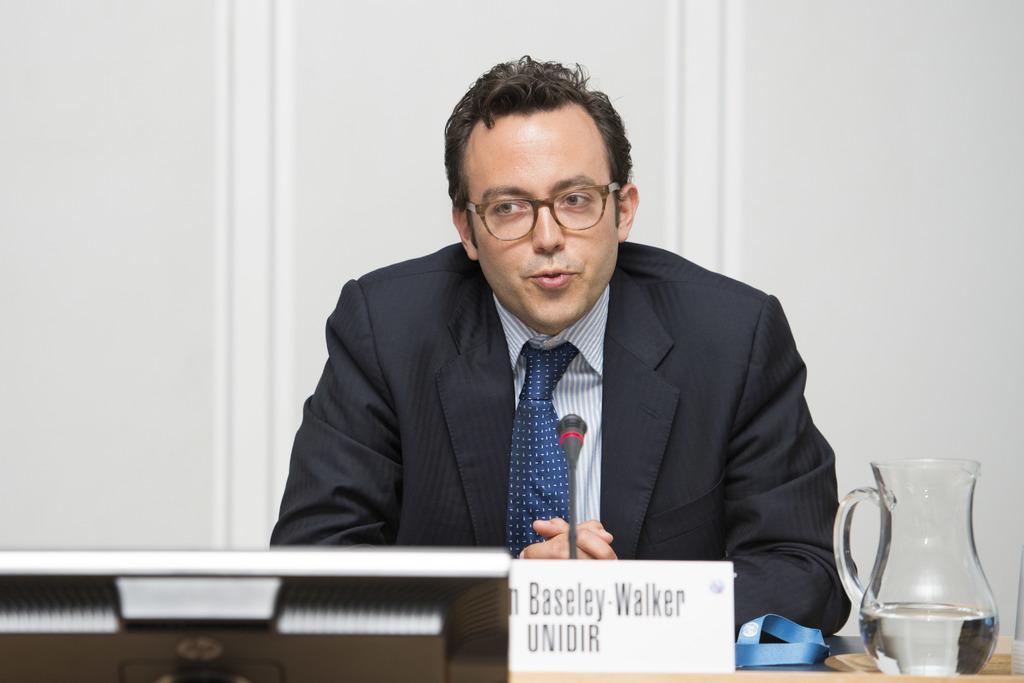In one or two sentences, can you explain what this image depicts? In this image in the front there is a monitor. In the center there is a name plate with some text written on it and there is a jar and in the background there is a person speaking and there is a mic in front of the person and behind the person there is a wall which is white in colour. 